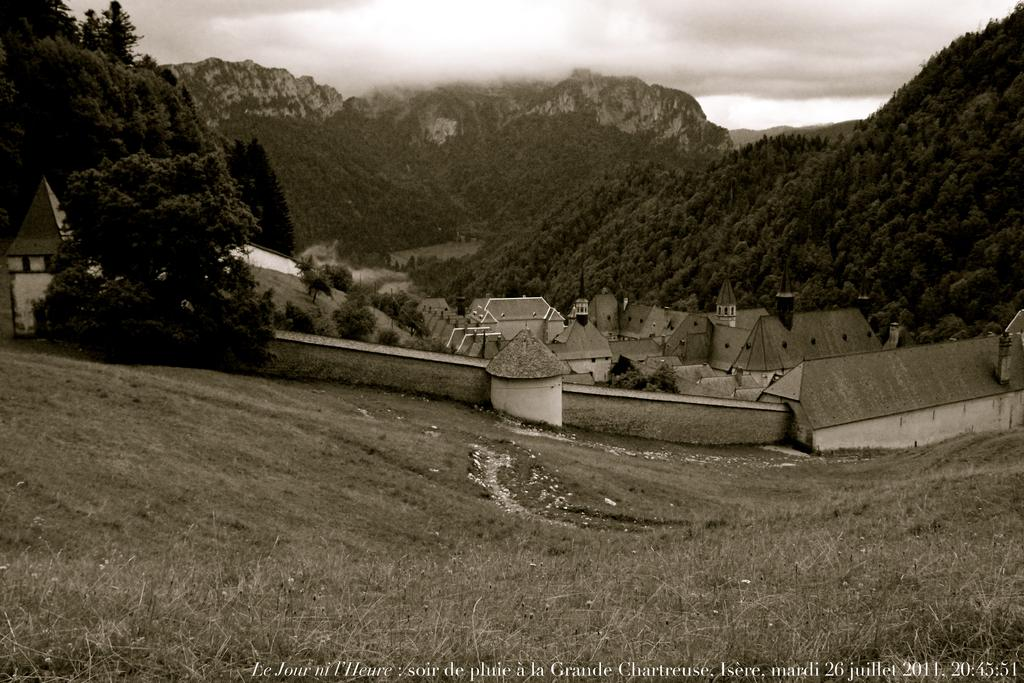What type of structures can be seen in the image? There are buildings in the image. What type of vegetation is visible in the image? There is grass visible in the image. What can be seen in the distance in the image? There are mountains and trees in the background of the image, and the sky is also visible. Is there any text or logo present in the image? Yes, there is a watermark present in the image. How much butter is present in the image? There is no butter present in the image. What trick can be performed with the trees in the background? There is no trick mentioned or implied in the image; it simply shows trees in the background. 